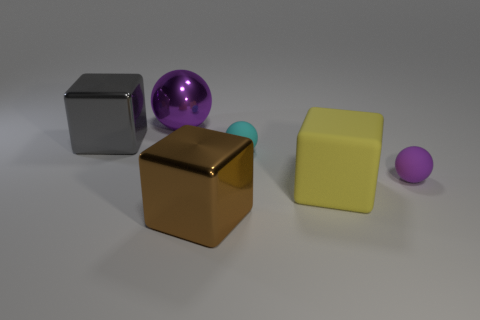Add 3 big brown shiny things. How many objects exist? 9 Subtract 0 brown balls. How many objects are left? 6 Subtract all tiny shiny blocks. Subtract all big gray blocks. How many objects are left? 5 Add 1 tiny cyan things. How many tiny cyan things are left? 2 Add 6 rubber spheres. How many rubber spheres exist? 8 